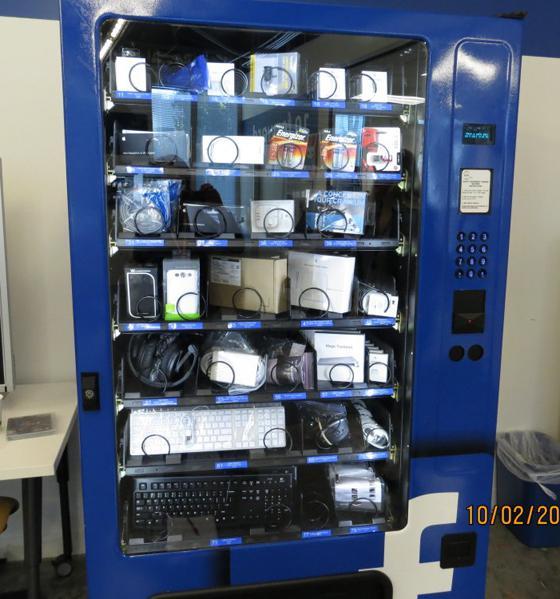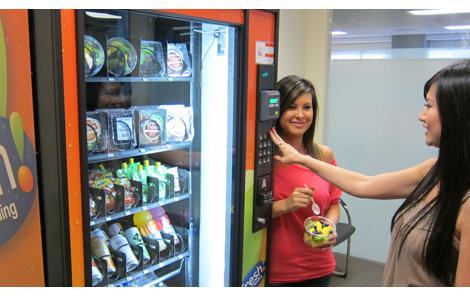The first image is the image on the left, the second image is the image on the right. Considering the images on both sides, is "Two people are shown at vending machines." valid? Answer yes or no. Yes. The first image is the image on the left, the second image is the image on the right. Given the left and right images, does the statement "Someone is touching a vending machine in the right image." hold true? Answer yes or no. Yes. 